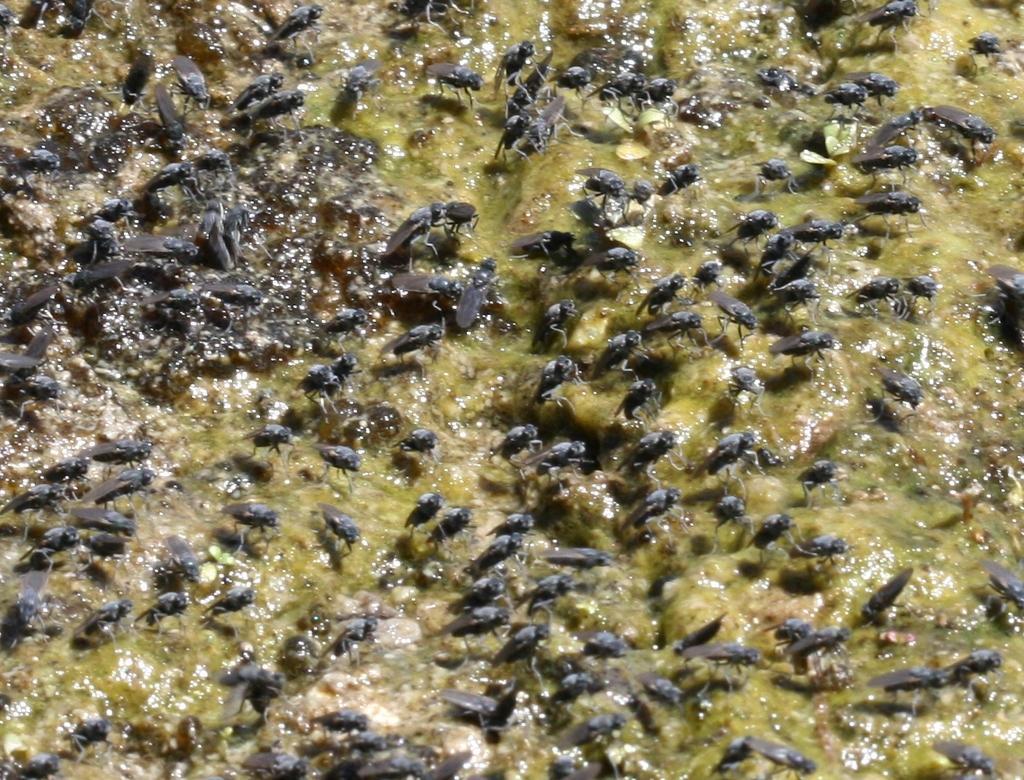Can you describe this image briefly? In this image there are insects on some surface. 